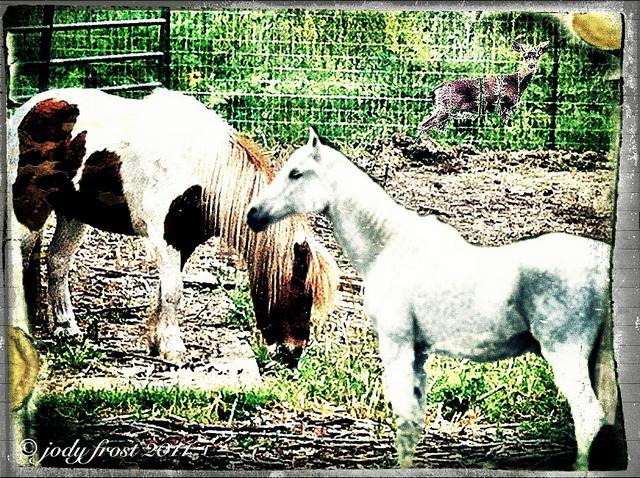Does the photograph have artistic borders?
Give a very brief answer. Yes. How many of the animals shown are being raised for their meat?
Quick response, please. 0. What animals are shown?
Be succinct. Horses. How many animals are in this picture?
Write a very short answer. 3. 